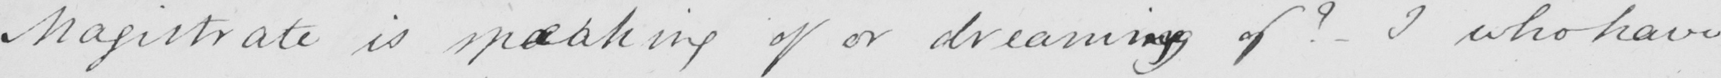Can you read and transcribe this handwriting? Magistrate is spaeaking of or dreaming of ?  - I who have 